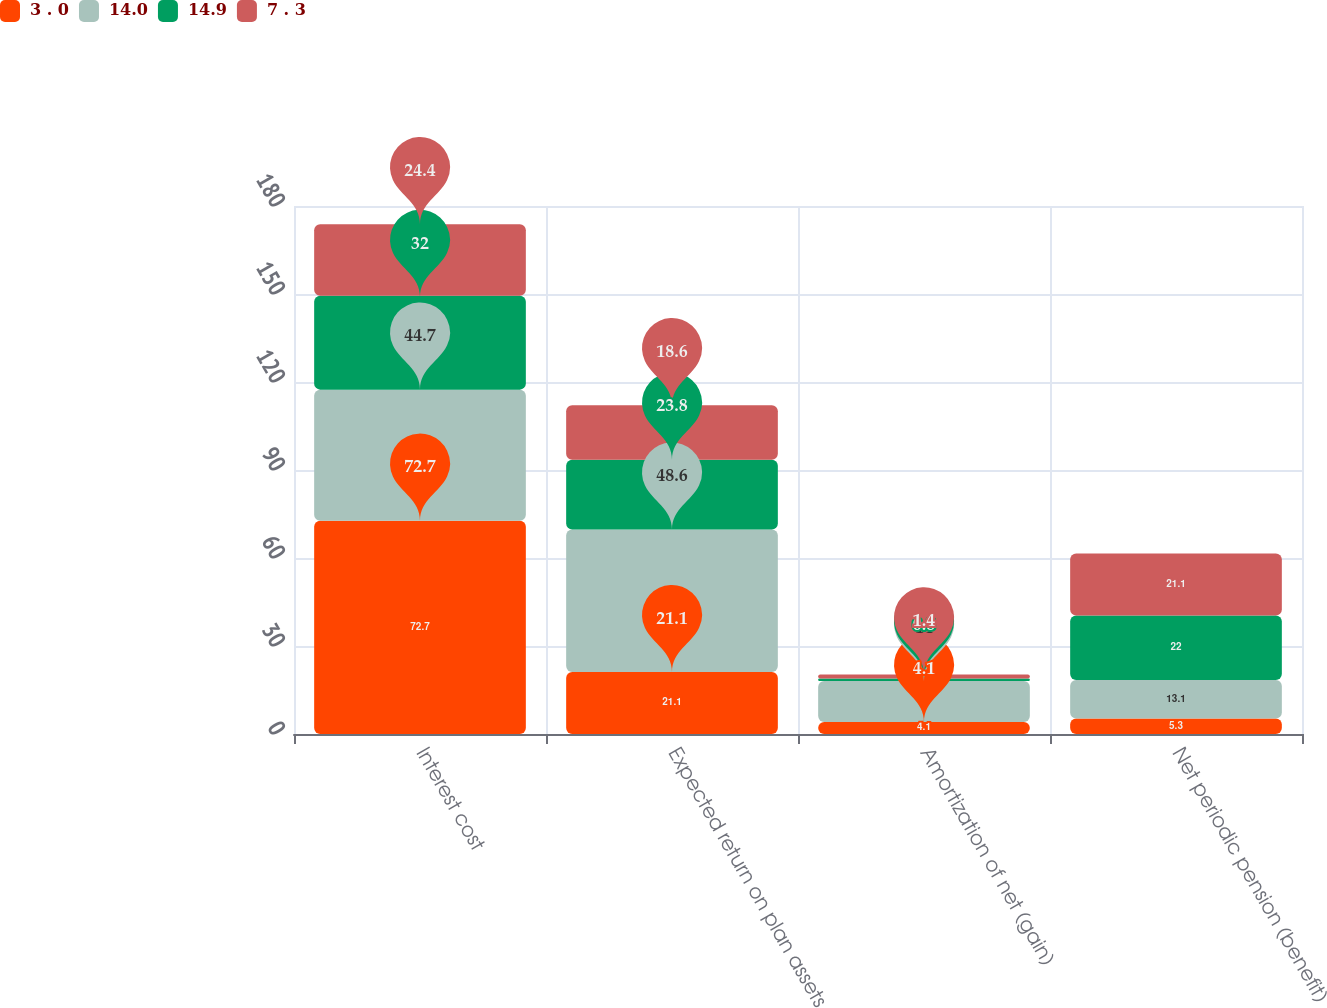<chart> <loc_0><loc_0><loc_500><loc_500><stacked_bar_chart><ecel><fcel>Interest cost<fcel>Expected return on plan assets<fcel>Amortization of net (gain)<fcel>Net periodic pension (benefit)<nl><fcel>3 . 0<fcel>72.7<fcel>21.1<fcel>4.1<fcel>5.3<nl><fcel>14.0<fcel>44.7<fcel>48.6<fcel>14<fcel>13.1<nl><fcel>14.9<fcel>32<fcel>23.8<fcel>0.8<fcel>22<nl><fcel>7 . 3<fcel>24.4<fcel>18.6<fcel>1.4<fcel>21.1<nl></chart> 